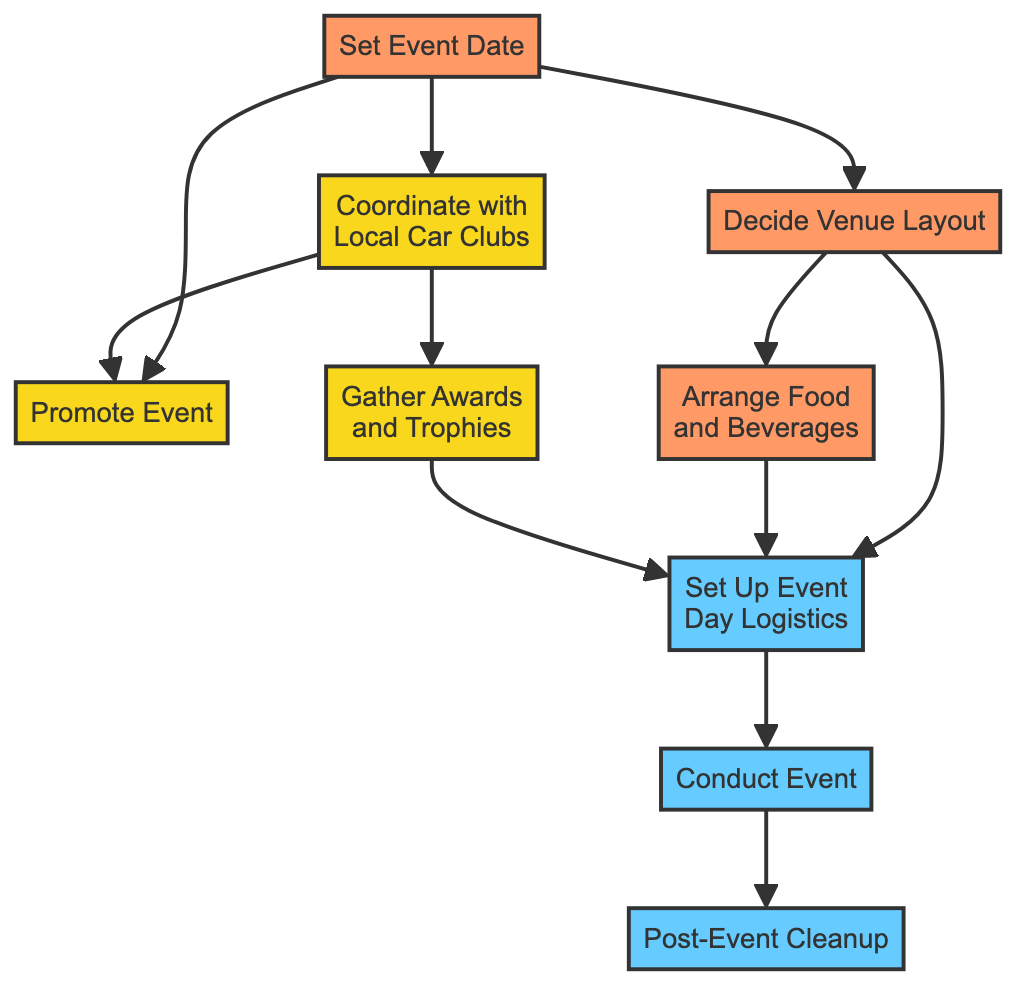What is the first task in the flow chart? The first task is indicated as "Set Event Date," which has no dependencies and starts the planning process.
Answer: Set Event Date How many total tasks are there in the flow chart? By counting all individual tasks represented as nodes in the flow chart, there are a total of nine tasks listed.
Answer: Nine What are the responsibilities for the task "Gather Awards and Trophies"? This task lists "Event Coordinator" as the sole responsibility, indicating that this individual is tasked with gathering the awards and trophies for the event.
Answer: Event Coordinator Which task has the most dependencies? "Set Up Event Day Logistics" has three dependencies: "Decide Venue Layout," "Arrange Food and Beverages," and "Gather Awards and Trophies," indicating that it relies on three preceding tasks to be completed.
Answer: Set Up Event Day Logistics What is the responsibility assigned to the "Promote Event" task? By checking the task "Promote Event," it is clear that the responsibility falls under the "Marketing Team," indicating that this team is in charge of promoting the event.
Answer: Marketing Team Which task follows "Conduct Event"? The task directly following "Conduct Event" is "Post-Event Cleanup," which indicates the next step after running the event itself.
Answer: Post-Event Cleanup What is the relationship between "Coordinate with Local Car Clubs" and "Promote Event"? "Coordinate with Local Car Clubs" is a prerequisite for "Promote Event," meaning that this coordination must be completed before promotion can begin.
Answer: Dependency List the responsibilities for the task "Arrange Food and Beverages". The responsibilities for this task are "Owner" and "Catering Supervisor," indicating that both roles are involved in arranging food and beverages for the event.
Answer: Owner, Catering Supervisor What is the last task in the flow chart? The last task is "Post-Event Cleanup," which is performed after the event concludes.
Answer: Post-Event Cleanup 